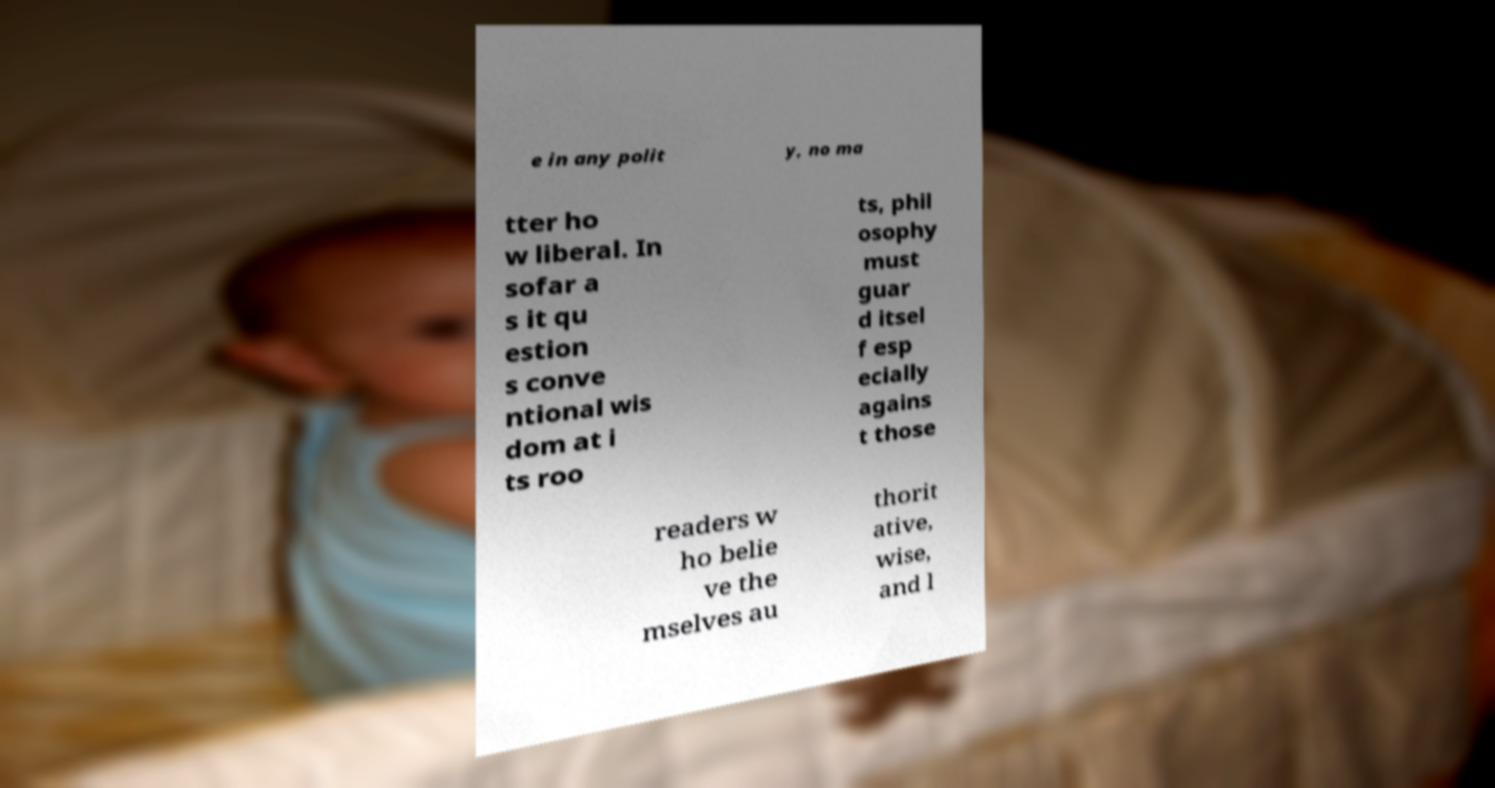I need the written content from this picture converted into text. Can you do that? e in any polit y, no ma tter ho w liberal. In sofar a s it qu estion s conve ntional wis dom at i ts roo ts, phil osophy must guar d itsel f esp ecially agains t those readers w ho belie ve the mselves au thorit ative, wise, and l 